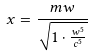<formula> <loc_0><loc_0><loc_500><loc_500>x = \frac { m w } { \sqrt { 1 \cdot \frac { w ^ { 5 } } { c ^ { 5 } } } }</formula> 